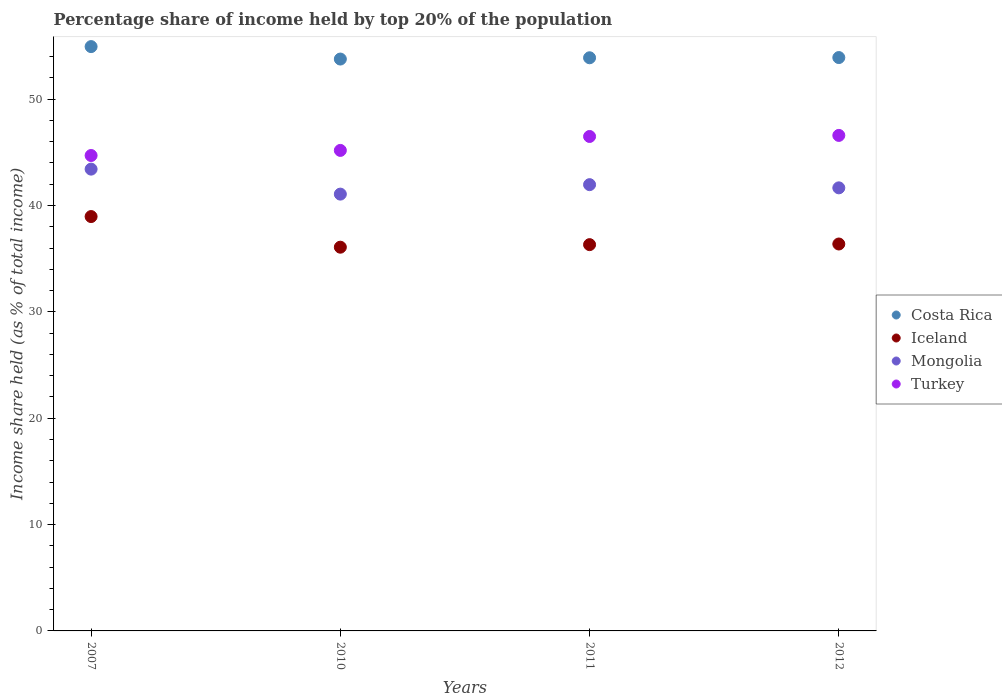What is the percentage share of income held by top 20% of the population in Mongolia in 2012?
Your answer should be very brief. 41.66. Across all years, what is the maximum percentage share of income held by top 20% of the population in Iceland?
Offer a very short reply. 38.96. Across all years, what is the minimum percentage share of income held by top 20% of the population in Iceland?
Offer a very short reply. 36.08. In which year was the percentage share of income held by top 20% of the population in Iceland minimum?
Give a very brief answer. 2010. What is the total percentage share of income held by top 20% of the population in Iceland in the graph?
Ensure brevity in your answer.  147.74. What is the difference between the percentage share of income held by top 20% of the population in Iceland in 2007 and that in 2011?
Your answer should be very brief. 2.64. What is the difference between the percentage share of income held by top 20% of the population in Turkey in 2012 and the percentage share of income held by top 20% of the population in Mongolia in 2007?
Make the answer very short. 3.17. What is the average percentage share of income held by top 20% of the population in Costa Rica per year?
Your answer should be compact. 54.13. In the year 2012, what is the difference between the percentage share of income held by top 20% of the population in Turkey and percentage share of income held by top 20% of the population in Iceland?
Your answer should be compact. 10.21. What is the ratio of the percentage share of income held by top 20% of the population in Turkey in 2007 to that in 2012?
Offer a very short reply. 0.96. Is the percentage share of income held by top 20% of the population in Mongolia in 2007 less than that in 2010?
Ensure brevity in your answer.  No. Is the difference between the percentage share of income held by top 20% of the population in Turkey in 2010 and 2012 greater than the difference between the percentage share of income held by top 20% of the population in Iceland in 2010 and 2012?
Your answer should be compact. No. What is the difference between the highest and the second highest percentage share of income held by top 20% of the population in Iceland?
Your answer should be very brief. 2.58. What is the difference between the highest and the lowest percentage share of income held by top 20% of the population in Iceland?
Offer a very short reply. 2.88. In how many years, is the percentage share of income held by top 20% of the population in Costa Rica greater than the average percentage share of income held by top 20% of the population in Costa Rica taken over all years?
Provide a short and direct response. 1. Is the sum of the percentage share of income held by top 20% of the population in Costa Rica in 2010 and 2012 greater than the maximum percentage share of income held by top 20% of the population in Iceland across all years?
Ensure brevity in your answer.  Yes. Is it the case that in every year, the sum of the percentage share of income held by top 20% of the population in Costa Rica and percentage share of income held by top 20% of the population in Turkey  is greater than the sum of percentage share of income held by top 20% of the population in Iceland and percentage share of income held by top 20% of the population in Mongolia?
Keep it short and to the point. Yes. Does the percentage share of income held by top 20% of the population in Costa Rica monotonically increase over the years?
Your answer should be compact. No. Is the percentage share of income held by top 20% of the population in Turkey strictly greater than the percentage share of income held by top 20% of the population in Costa Rica over the years?
Your response must be concise. No. What is the difference between two consecutive major ticks on the Y-axis?
Offer a terse response. 10. What is the title of the graph?
Your response must be concise. Percentage share of income held by top 20% of the population. What is the label or title of the Y-axis?
Offer a very short reply. Income share held (as % of total income). What is the Income share held (as % of total income) in Costa Rica in 2007?
Your answer should be very brief. 54.94. What is the Income share held (as % of total income) in Iceland in 2007?
Offer a terse response. 38.96. What is the Income share held (as % of total income) in Mongolia in 2007?
Ensure brevity in your answer.  43.42. What is the Income share held (as % of total income) in Turkey in 2007?
Give a very brief answer. 44.7. What is the Income share held (as % of total income) of Costa Rica in 2010?
Make the answer very short. 53.77. What is the Income share held (as % of total income) of Iceland in 2010?
Your response must be concise. 36.08. What is the Income share held (as % of total income) of Mongolia in 2010?
Offer a terse response. 41.07. What is the Income share held (as % of total income) in Turkey in 2010?
Offer a very short reply. 45.18. What is the Income share held (as % of total income) of Costa Rica in 2011?
Your response must be concise. 53.89. What is the Income share held (as % of total income) of Iceland in 2011?
Ensure brevity in your answer.  36.32. What is the Income share held (as % of total income) of Mongolia in 2011?
Provide a short and direct response. 41.96. What is the Income share held (as % of total income) in Turkey in 2011?
Make the answer very short. 46.49. What is the Income share held (as % of total income) in Costa Rica in 2012?
Offer a very short reply. 53.91. What is the Income share held (as % of total income) in Iceland in 2012?
Your response must be concise. 36.38. What is the Income share held (as % of total income) of Mongolia in 2012?
Your answer should be compact. 41.66. What is the Income share held (as % of total income) of Turkey in 2012?
Your answer should be compact. 46.59. Across all years, what is the maximum Income share held (as % of total income) in Costa Rica?
Give a very brief answer. 54.94. Across all years, what is the maximum Income share held (as % of total income) of Iceland?
Your response must be concise. 38.96. Across all years, what is the maximum Income share held (as % of total income) in Mongolia?
Make the answer very short. 43.42. Across all years, what is the maximum Income share held (as % of total income) in Turkey?
Make the answer very short. 46.59. Across all years, what is the minimum Income share held (as % of total income) in Costa Rica?
Give a very brief answer. 53.77. Across all years, what is the minimum Income share held (as % of total income) in Iceland?
Offer a terse response. 36.08. Across all years, what is the minimum Income share held (as % of total income) of Mongolia?
Your answer should be very brief. 41.07. Across all years, what is the minimum Income share held (as % of total income) of Turkey?
Offer a terse response. 44.7. What is the total Income share held (as % of total income) in Costa Rica in the graph?
Make the answer very short. 216.51. What is the total Income share held (as % of total income) in Iceland in the graph?
Provide a succinct answer. 147.74. What is the total Income share held (as % of total income) in Mongolia in the graph?
Provide a succinct answer. 168.11. What is the total Income share held (as % of total income) in Turkey in the graph?
Make the answer very short. 182.96. What is the difference between the Income share held (as % of total income) in Costa Rica in 2007 and that in 2010?
Provide a short and direct response. 1.17. What is the difference between the Income share held (as % of total income) of Iceland in 2007 and that in 2010?
Offer a very short reply. 2.88. What is the difference between the Income share held (as % of total income) in Mongolia in 2007 and that in 2010?
Make the answer very short. 2.35. What is the difference between the Income share held (as % of total income) in Turkey in 2007 and that in 2010?
Make the answer very short. -0.48. What is the difference between the Income share held (as % of total income) of Costa Rica in 2007 and that in 2011?
Your answer should be compact. 1.05. What is the difference between the Income share held (as % of total income) in Iceland in 2007 and that in 2011?
Make the answer very short. 2.64. What is the difference between the Income share held (as % of total income) in Mongolia in 2007 and that in 2011?
Give a very brief answer. 1.46. What is the difference between the Income share held (as % of total income) in Turkey in 2007 and that in 2011?
Ensure brevity in your answer.  -1.79. What is the difference between the Income share held (as % of total income) in Iceland in 2007 and that in 2012?
Your answer should be compact. 2.58. What is the difference between the Income share held (as % of total income) in Mongolia in 2007 and that in 2012?
Offer a very short reply. 1.76. What is the difference between the Income share held (as % of total income) of Turkey in 2007 and that in 2012?
Provide a succinct answer. -1.89. What is the difference between the Income share held (as % of total income) of Costa Rica in 2010 and that in 2011?
Provide a succinct answer. -0.12. What is the difference between the Income share held (as % of total income) of Iceland in 2010 and that in 2011?
Ensure brevity in your answer.  -0.24. What is the difference between the Income share held (as % of total income) in Mongolia in 2010 and that in 2011?
Offer a very short reply. -0.89. What is the difference between the Income share held (as % of total income) of Turkey in 2010 and that in 2011?
Your answer should be compact. -1.31. What is the difference between the Income share held (as % of total income) of Costa Rica in 2010 and that in 2012?
Offer a terse response. -0.14. What is the difference between the Income share held (as % of total income) in Mongolia in 2010 and that in 2012?
Offer a terse response. -0.59. What is the difference between the Income share held (as % of total income) in Turkey in 2010 and that in 2012?
Ensure brevity in your answer.  -1.41. What is the difference between the Income share held (as % of total income) in Costa Rica in 2011 and that in 2012?
Provide a succinct answer. -0.02. What is the difference between the Income share held (as % of total income) of Iceland in 2011 and that in 2012?
Ensure brevity in your answer.  -0.06. What is the difference between the Income share held (as % of total income) in Costa Rica in 2007 and the Income share held (as % of total income) in Iceland in 2010?
Offer a terse response. 18.86. What is the difference between the Income share held (as % of total income) of Costa Rica in 2007 and the Income share held (as % of total income) of Mongolia in 2010?
Keep it short and to the point. 13.87. What is the difference between the Income share held (as % of total income) of Costa Rica in 2007 and the Income share held (as % of total income) of Turkey in 2010?
Your response must be concise. 9.76. What is the difference between the Income share held (as % of total income) in Iceland in 2007 and the Income share held (as % of total income) in Mongolia in 2010?
Your answer should be compact. -2.11. What is the difference between the Income share held (as % of total income) of Iceland in 2007 and the Income share held (as % of total income) of Turkey in 2010?
Your response must be concise. -6.22. What is the difference between the Income share held (as % of total income) of Mongolia in 2007 and the Income share held (as % of total income) of Turkey in 2010?
Offer a terse response. -1.76. What is the difference between the Income share held (as % of total income) of Costa Rica in 2007 and the Income share held (as % of total income) of Iceland in 2011?
Provide a short and direct response. 18.62. What is the difference between the Income share held (as % of total income) in Costa Rica in 2007 and the Income share held (as % of total income) in Mongolia in 2011?
Offer a terse response. 12.98. What is the difference between the Income share held (as % of total income) of Costa Rica in 2007 and the Income share held (as % of total income) of Turkey in 2011?
Make the answer very short. 8.45. What is the difference between the Income share held (as % of total income) in Iceland in 2007 and the Income share held (as % of total income) in Turkey in 2011?
Offer a terse response. -7.53. What is the difference between the Income share held (as % of total income) of Mongolia in 2007 and the Income share held (as % of total income) of Turkey in 2011?
Offer a terse response. -3.07. What is the difference between the Income share held (as % of total income) in Costa Rica in 2007 and the Income share held (as % of total income) in Iceland in 2012?
Your answer should be very brief. 18.56. What is the difference between the Income share held (as % of total income) of Costa Rica in 2007 and the Income share held (as % of total income) of Mongolia in 2012?
Ensure brevity in your answer.  13.28. What is the difference between the Income share held (as % of total income) in Costa Rica in 2007 and the Income share held (as % of total income) in Turkey in 2012?
Provide a short and direct response. 8.35. What is the difference between the Income share held (as % of total income) in Iceland in 2007 and the Income share held (as % of total income) in Turkey in 2012?
Provide a short and direct response. -7.63. What is the difference between the Income share held (as % of total income) of Mongolia in 2007 and the Income share held (as % of total income) of Turkey in 2012?
Your answer should be compact. -3.17. What is the difference between the Income share held (as % of total income) of Costa Rica in 2010 and the Income share held (as % of total income) of Iceland in 2011?
Your answer should be very brief. 17.45. What is the difference between the Income share held (as % of total income) in Costa Rica in 2010 and the Income share held (as % of total income) in Mongolia in 2011?
Keep it short and to the point. 11.81. What is the difference between the Income share held (as % of total income) of Costa Rica in 2010 and the Income share held (as % of total income) of Turkey in 2011?
Your answer should be compact. 7.28. What is the difference between the Income share held (as % of total income) in Iceland in 2010 and the Income share held (as % of total income) in Mongolia in 2011?
Offer a very short reply. -5.88. What is the difference between the Income share held (as % of total income) of Iceland in 2010 and the Income share held (as % of total income) of Turkey in 2011?
Offer a very short reply. -10.41. What is the difference between the Income share held (as % of total income) in Mongolia in 2010 and the Income share held (as % of total income) in Turkey in 2011?
Offer a terse response. -5.42. What is the difference between the Income share held (as % of total income) of Costa Rica in 2010 and the Income share held (as % of total income) of Iceland in 2012?
Offer a terse response. 17.39. What is the difference between the Income share held (as % of total income) in Costa Rica in 2010 and the Income share held (as % of total income) in Mongolia in 2012?
Offer a terse response. 12.11. What is the difference between the Income share held (as % of total income) in Costa Rica in 2010 and the Income share held (as % of total income) in Turkey in 2012?
Your response must be concise. 7.18. What is the difference between the Income share held (as % of total income) in Iceland in 2010 and the Income share held (as % of total income) in Mongolia in 2012?
Keep it short and to the point. -5.58. What is the difference between the Income share held (as % of total income) of Iceland in 2010 and the Income share held (as % of total income) of Turkey in 2012?
Make the answer very short. -10.51. What is the difference between the Income share held (as % of total income) of Mongolia in 2010 and the Income share held (as % of total income) of Turkey in 2012?
Offer a terse response. -5.52. What is the difference between the Income share held (as % of total income) in Costa Rica in 2011 and the Income share held (as % of total income) in Iceland in 2012?
Your response must be concise. 17.51. What is the difference between the Income share held (as % of total income) in Costa Rica in 2011 and the Income share held (as % of total income) in Mongolia in 2012?
Offer a very short reply. 12.23. What is the difference between the Income share held (as % of total income) of Iceland in 2011 and the Income share held (as % of total income) of Mongolia in 2012?
Give a very brief answer. -5.34. What is the difference between the Income share held (as % of total income) of Iceland in 2011 and the Income share held (as % of total income) of Turkey in 2012?
Your answer should be compact. -10.27. What is the difference between the Income share held (as % of total income) in Mongolia in 2011 and the Income share held (as % of total income) in Turkey in 2012?
Ensure brevity in your answer.  -4.63. What is the average Income share held (as % of total income) in Costa Rica per year?
Ensure brevity in your answer.  54.13. What is the average Income share held (as % of total income) in Iceland per year?
Your answer should be compact. 36.94. What is the average Income share held (as % of total income) in Mongolia per year?
Offer a terse response. 42.03. What is the average Income share held (as % of total income) in Turkey per year?
Ensure brevity in your answer.  45.74. In the year 2007, what is the difference between the Income share held (as % of total income) of Costa Rica and Income share held (as % of total income) of Iceland?
Your answer should be compact. 15.98. In the year 2007, what is the difference between the Income share held (as % of total income) in Costa Rica and Income share held (as % of total income) in Mongolia?
Provide a succinct answer. 11.52. In the year 2007, what is the difference between the Income share held (as % of total income) of Costa Rica and Income share held (as % of total income) of Turkey?
Offer a very short reply. 10.24. In the year 2007, what is the difference between the Income share held (as % of total income) of Iceland and Income share held (as % of total income) of Mongolia?
Provide a short and direct response. -4.46. In the year 2007, what is the difference between the Income share held (as % of total income) of Iceland and Income share held (as % of total income) of Turkey?
Keep it short and to the point. -5.74. In the year 2007, what is the difference between the Income share held (as % of total income) of Mongolia and Income share held (as % of total income) of Turkey?
Ensure brevity in your answer.  -1.28. In the year 2010, what is the difference between the Income share held (as % of total income) in Costa Rica and Income share held (as % of total income) in Iceland?
Give a very brief answer. 17.69. In the year 2010, what is the difference between the Income share held (as % of total income) of Costa Rica and Income share held (as % of total income) of Turkey?
Offer a terse response. 8.59. In the year 2010, what is the difference between the Income share held (as % of total income) of Iceland and Income share held (as % of total income) of Mongolia?
Your answer should be very brief. -4.99. In the year 2010, what is the difference between the Income share held (as % of total income) in Mongolia and Income share held (as % of total income) in Turkey?
Keep it short and to the point. -4.11. In the year 2011, what is the difference between the Income share held (as % of total income) of Costa Rica and Income share held (as % of total income) of Iceland?
Give a very brief answer. 17.57. In the year 2011, what is the difference between the Income share held (as % of total income) in Costa Rica and Income share held (as % of total income) in Mongolia?
Ensure brevity in your answer.  11.93. In the year 2011, what is the difference between the Income share held (as % of total income) in Costa Rica and Income share held (as % of total income) in Turkey?
Offer a terse response. 7.4. In the year 2011, what is the difference between the Income share held (as % of total income) of Iceland and Income share held (as % of total income) of Mongolia?
Offer a very short reply. -5.64. In the year 2011, what is the difference between the Income share held (as % of total income) of Iceland and Income share held (as % of total income) of Turkey?
Ensure brevity in your answer.  -10.17. In the year 2011, what is the difference between the Income share held (as % of total income) of Mongolia and Income share held (as % of total income) of Turkey?
Give a very brief answer. -4.53. In the year 2012, what is the difference between the Income share held (as % of total income) of Costa Rica and Income share held (as % of total income) of Iceland?
Make the answer very short. 17.53. In the year 2012, what is the difference between the Income share held (as % of total income) of Costa Rica and Income share held (as % of total income) of Mongolia?
Your answer should be very brief. 12.25. In the year 2012, what is the difference between the Income share held (as % of total income) in Costa Rica and Income share held (as % of total income) in Turkey?
Keep it short and to the point. 7.32. In the year 2012, what is the difference between the Income share held (as % of total income) in Iceland and Income share held (as % of total income) in Mongolia?
Keep it short and to the point. -5.28. In the year 2012, what is the difference between the Income share held (as % of total income) of Iceland and Income share held (as % of total income) of Turkey?
Make the answer very short. -10.21. In the year 2012, what is the difference between the Income share held (as % of total income) of Mongolia and Income share held (as % of total income) of Turkey?
Keep it short and to the point. -4.93. What is the ratio of the Income share held (as % of total income) in Costa Rica in 2007 to that in 2010?
Provide a succinct answer. 1.02. What is the ratio of the Income share held (as % of total income) in Iceland in 2007 to that in 2010?
Keep it short and to the point. 1.08. What is the ratio of the Income share held (as % of total income) in Mongolia in 2007 to that in 2010?
Ensure brevity in your answer.  1.06. What is the ratio of the Income share held (as % of total income) in Costa Rica in 2007 to that in 2011?
Your answer should be very brief. 1.02. What is the ratio of the Income share held (as % of total income) in Iceland in 2007 to that in 2011?
Your answer should be compact. 1.07. What is the ratio of the Income share held (as % of total income) of Mongolia in 2007 to that in 2011?
Keep it short and to the point. 1.03. What is the ratio of the Income share held (as % of total income) in Turkey in 2007 to that in 2011?
Provide a short and direct response. 0.96. What is the ratio of the Income share held (as % of total income) of Costa Rica in 2007 to that in 2012?
Keep it short and to the point. 1.02. What is the ratio of the Income share held (as % of total income) of Iceland in 2007 to that in 2012?
Keep it short and to the point. 1.07. What is the ratio of the Income share held (as % of total income) in Mongolia in 2007 to that in 2012?
Make the answer very short. 1.04. What is the ratio of the Income share held (as % of total income) in Turkey in 2007 to that in 2012?
Keep it short and to the point. 0.96. What is the ratio of the Income share held (as % of total income) of Iceland in 2010 to that in 2011?
Your answer should be very brief. 0.99. What is the ratio of the Income share held (as % of total income) of Mongolia in 2010 to that in 2011?
Your response must be concise. 0.98. What is the ratio of the Income share held (as % of total income) in Turkey in 2010 to that in 2011?
Your response must be concise. 0.97. What is the ratio of the Income share held (as % of total income) in Mongolia in 2010 to that in 2012?
Ensure brevity in your answer.  0.99. What is the ratio of the Income share held (as % of total income) in Turkey in 2010 to that in 2012?
Your answer should be compact. 0.97. What is the ratio of the Income share held (as % of total income) in Costa Rica in 2011 to that in 2012?
Provide a short and direct response. 1. What is the difference between the highest and the second highest Income share held (as % of total income) in Iceland?
Offer a very short reply. 2.58. What is the difference between the highest and the second highest Income share held (as % of total income) in Mongolia?
Your answer should be very brief. 1.46. What is the difference between the highest and the second highest Income share held (as % of total income) in Turkey?
Your answer should be compact. 0.1. What is the difference between the highest and the lowest Income share held (as % of total income) of Costa Rica?
Give a very brief answer. 1.17. What is the difference between the highest and the lowest Income share held (as % of total income) of Iceland?
Provide a succinct answer. 2.88. What is the difference between the highest and the lowest Income share held (as % of total income) of Mongolia?
Provide a succinct answer. 2.35. What is the difference between the highest and the lowest Income share held (as % of total income) in Turkey?
Make the answer very short. 1.89. 